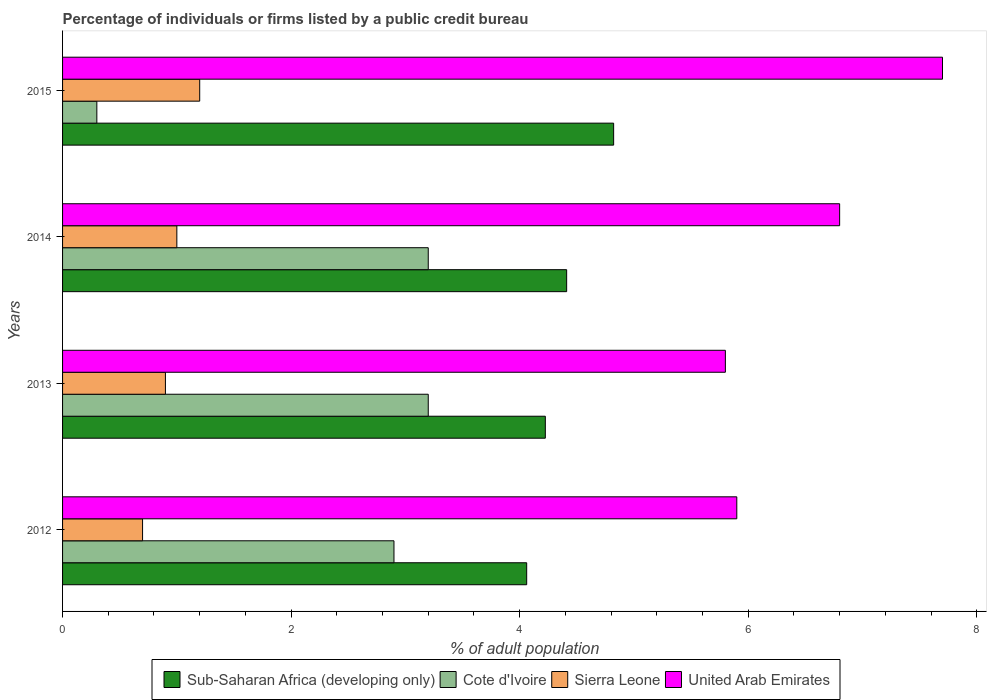How many different coloured bars are there?
Your answer should be compact. 4. How many bars are there on the 3rd tick from the bottom?
Your answer should be compact. 4. What is the label of the 1st group of bars from the top?
Provide a short and direct response. 2015. What is the percentage of population listed by a public credit bureau in Sub-Saharan Africa (developing only) in 2012?
Your answer should be very brief. 4.06. Across all years, what is the maximum percentage of population listed by a public credit bureau in Sierra Leone?
Ensure brevity in your answer.  1.2. Across all years, what is the minimum percentage of population listed by a public credit bureau in United Arab Emirates?
Offer a very short reply. 5.8. In which year was the percentage of population listed by a public credit bureau in United Arab Emirates maximum?
Provide a short and direct response. 2015. In which year was the percentage of population listed by a public credit bureau in Cote d'Ivoire minimum?
Provide a succinct answer. 2015. What is the total percentage of population listed by a public credit bureau in Sub-Saharan Africa (developing only) in the graph?
Your response must be concise. 17.52. What is the difference between the percentage of population listed by a public credit bureau in United Arab Emirates in 2013 and that in 2014?
Give a very brief answer. -1. What is the difference between the percentage of population listed by a public credit bureau in United Arab Emirates in 2013 and the percentage of population listed by a public credit bureau in Cote d'Ivoire in 2015?
Provide a succinct answer. 5.5. What is the average percentage of population listed by a public credit bureau in Sub-Saharan Africa (developing only) per year?
Offer a very short reply. 4.38. In the year 2015, what is the difference between the percentage of population listed by a public credit bureau in Sierra Leone and percentage of population listed by a public credit bureau in Cote d'Ivoire?
Your response must be concise. 0.9. In how many years, is the percentage of population listed by a public credit bureau in Cote d'Ivoire greater than 4.4 %?
Give a very brief answer. 0. What is the ratio of the percentage of population listed by a public credit bureau in Sub-Saharan Africa (developing only) in 2013 to that in 2015?
Offer a very short reply. 0.88. Is the percentage of population listed by a public credit bureau in Sub-Saharan Africa (developing only) in 2012 less than that in 2013?
Offer a very short reply. Yes. Is the difference between the percentage of population listed by a public credit bureau in Sierra Leone in 2013 and 2015 greater than the difference between the percentage of population listed by a public credit bureau in Cote d'Ivoire in 2013 and 2015?
Offer a terse response. No. What is the difference between the highest and the second highest percentage of population listed by a public credit bureau in Cote d'Ivoire?
Provide a succinct answer. 0. In how many years, is the percentage of population listed by a public credit bureau in Sierra Leone greater than the average percentage of population listed by a public credit bureau in Sierra Leone taken over all years?
Keep it short and to the point. 2. What does the 3rd bar from the top in 2014 represents?
Your response must be concise. Cote d'Ivoire. What does the 3rd bar from the bottom in 2012 represents?
Your answer should be very brief. Sierra Leone. How many bars are there?
Ensure brevity in your answer.  16. Are all the bars in the graph horizontal?
Provide a succinct answer. Yes. What is the difference between two consecutive major ticks on the X-axis?
Your answer should be compact. 2. Does the graph contain any zero values?
Offer a very short reply. No. Where does the legend appear in the graph?
Make the answer very short. Bottom center. How many legend labels are there?
Your response must be concise. 4. What is the title of the graph?
Your answer should be compact. Percentage of individuals or firms listed by a public credit bureau. Does "Pakistan" appear as one of the legend labels in the graph?
Provide a succinct answer. No. What is the label or title of the X-axis?
Ensure brevity in your answer.  % of adult population. What is the % of adult population of Sub-Saharan Africa (developing only) in 2012?
Provide a succinct answer. 4.06. What is the % of adult population of Cote d'Ivoire in 2012?
Ensure brevity in your answer.  2.9. What is the % of adult population of Sierra Leone in 2012?
Provide a succinct answer. 0.7. What is the % of adult population in Sub-Saharan Africa (developing only) in 2013?
Your answer should be very brief. 4.22. What is the % of adult population in Cote d'Ivoire in 2013?
Provide a short and direct response. 3.2. What is the % of adult population of Sierra Leone in 2013?
Make the answer very short. 0.9. What is the % of adult population of Sub-Saharan Africa (developing only) in 2014?
Your answer should be compact. 4.41. What is the % of adult population in United Arab Emirates in 2014?
Make the answer very short. 6.8. What is the % of adult population in Sub-Saharan Africa (developing only) in 2015?
Provide a short and direct response. 4.82. What is the % of adult population in Sierra Leone in 2015?
Give a very brief answer. 1.2. What is the % of adult population of United Arab Emirates in 2015?
Provide a short and direct response. 7.7. Across all years, what is the maximum % of adult population of Sub-Saharan Africa (developing only)?
Offer a terse response. 4.82. Across all years, what is the maximum % of adult population in Cote d'Ivoire?
Your answer should be compact. 3.2. Across all years, what is the maximum % of adult population of Sierra Leone?
Your answer should be compact. 1.2. Across all years, what is the minimum % of adult population of Sub-Saharan Africa (developing only)?
Keep it short and to the point. 4.06. Across all years, what is the minimum % of adult population of Cote d'Ivoire?
Make the answer very short. 0.3. Across all years, what is the minimum % of adult population of Sierra Leone?
Give a very brief answer. 0.7. Across all years, what is the minimum % of adult population of United Arab Emirates?
Your response must be concise. 5.8. What is the total % of adult population of Sub-Saharan Africa (developing only) in the graph?
Give a very brief answer. 17.52. What is the total % of adult population in Sierra Leone in the graph?
Offer a terse response. 3.8. What is the total % of adult population of United Arab Emirates in the graph?
Your answer should be very brief. 26.2. What is the difference between the % of adult population of Sub-Saharan Africa (developing only) in 2012 and that in 2013?
Make the answer very short. -0.16. What is the difference between the % of adult population of Sierra Leone in 2012 and that in 2013?
Provide a short and direct response. -0.2. What is the difference between the % of adult population of Sub-Saharan Africa (developing only) in 2012 and that in 2014?
Provide a short and direct response. -0.35. What is the difference between the % of adult population of Sierra Leone in 2012 and that in 2014?
Provide a succinct answer. -0.3. What is the difference between the % of adult population of United Arab Emirates in 2012 and that in 2014?
Your response must be concise. -0.9. What is the difference between the % of adult population in Sub-Saharan Africa (developing only) in 2012 and that in 2015?
Provide a succinct answer. -0.76. What is the difference between the % of adult population of Cote d'Ivoire in 2012 and that in 2015?
Your answer should be compact. 2.6. What is the difference between the % of adult population in Sierra Leone in 2012 and that in 2015?
Your answer should be very brief. -0.5. What is the difference between the % of adult population of United Arab Emirates in 2012 and that in 2015?
Make the answer very short. -1.8. What is the difference between the % of adult population in Sub-Saharan Africa (developing only) in 2013 and that in 2014?
Make the answer very short. -0.19. What is the difference between the % of adult population of Sierra Leone in 2013 and that in 2014?
Make the answer very short. -0.1. What is the difference between the % of adult population of Sub-Saharan Africa (developing only) in 2013 and that in 2015?
Give a very brief answer. -0.6. What is the difference between the % of adult population in Cote d'Ivoire in 2013 and that in 2015?
Offer a terse response. 2.9. What is the difference between the % of adult population in United Arab Emirates in 2013 and that in 2015?
Make the answer very short. -1.9. What is the difference between the % of adult population of Sub-Saharan Africa (developing only) in 2014 and that in 2015?
Ensure brevity in your answer.  -0.41. What is the difference between the % of adult population in Cote d'Ivoire in 2014 and that in 2015?
Keep it short and to the point. 2.9. What is the difference between the % of adult population in United Arab Emirates in 2014 and that in 2015?
Make the answer very short. -0.9. What is the difference between the % of adult population of Sub-Saharan Africa (developing only) in 2012 and the % of adult population of Cote d'Ivoire in 2013?
Your answer should be compact. 0.86. What is the difference between the % of adult population in Sub-Saharan Africa (developing only) in 2012 and the % of adult population in Sierra Leone in 2013?
Keep it short and to the point. 3.16. What is the difference between the % of adult population of Sub-Saharan Africa (developing only) in 2012 and the % of adult population of United Arab Emirates in 2013?
Your response must be concise. -1.74. What is the difference between the % of adult population of Cote d'Ivoire in 2012 and the % of adult population of Sierra Leone in 2013?
Your response must be concise. 2. What is the difference between the % of adult population in Cote d'Ivoire in 2012 and the % of adult population in United Arab Emirates in 2013?
Make the answer very short. -2.9. What is the difference between the % of adult population in Sierra Leone in 2012 and the % of adult population in United Arab Emirates in 2013?
Make the answer very short. -5.1. What is the difference between the % of adult population of Sub-Saharan Africa (developing only) in 2012 and the % of adult population of Cote d'Ivoire in 2014?
Provide a short and direct response. 0.86. What is the difference between the % of adult population in Sub-Saharan Africa (developing only) in 2012 and the % of adult population in Sierra Leone in 2014?
Ensure brevity in your answer.  3.06. What is the difference between the % of adult population in Sub-Saharan Africa (developing only) in 2012 and the % of adult population in United Arab Emirates in 2014?
Give a very brief answer. -2.74. What is the difference between the % of adult population of Cote d'Ivoire in 2012 and the % of adult population of United Arab Emirates in 2014?
Provide a short and direct response. -3.9. What is the difference between the % of adult population of Sub-Saharan Africa (developing only) in 2012 and the % of adult population of Cote d'Ivoire in 2015?
Make the answer very short. 3.76. What is the difference between the % of adult population of Sub-Saharan Africa (developing only) in 2012 and the % of adult population of Sierra Leone in 2015?
Your answer should be very brief. 2.86. What is the difference between the % of adult population of Sub-Saharan Africa (developing only) in 2012 and the % of adult population of United Arab Emirates in 2015?
Offer a terse response. -3.64. What is the difference between the % of adult population in Cote d'Ivoire in 2012 and the % of adult population in United Arab Emirates in 2015?
Give a very brief answer. -4.8. What is the difference between the % of adult population in Sierra Leone in 2012 and the % of adult population in United Arab Emirates in 2015?
Keep it short and to the point. -7. What is the difference between the % of adult population in Sub-Saharan Africa (developing only) in 2013 and the % of adult population in Cote d'Ivoire in 2014?
Offer a terse response. 1.02. What is the difference between the % of adult population of Sub-Saharan Africa (developing only) in 2013 and the % of adult population of Sierra Leone in 2014?
Provide a short and direct response. 3.22. What is the difference between the % of adult population in Sub-Saharan Africa (developing only) in 2013 and the % of adult population in United Arab Emirates in 2014?
Keep it short and to the point. -2.58. What is the difference between the % of adult population of Cote d'Ivoire in 2013 and the % of adult population of Sierra Leone in 2014?
Your answer should be very brief. 2.2. What is the difference between the % of adult population of Sub-Saharan Africa (developing only) in 2013 and the % of adult population of Cote d'Ivoire in 2015?
Keep it short and to the point. 3.92. What is the difference between the % of adult population in Sub-Saharan Africa (developing only) in 2013 and the % of adult population in Sierra Leone in 2015?
Make the answer very short. 3.02. What is the difference between the % of adult population in Sub-Saharan Africa (developing only) in 2013 and the % of adult population in United Arab Emirates in 2015?
Your answer should be very brief. -3.48. What is the difference between the % of adult population in Sub-Saharan Africa (developing only) in 2014 and the % of adult population in Cote d'Ivoire in 2015?
Offer a terse response. 4.11. What is the difference between the % of adult population in Sub-Saharan Africa (developing only) in 2014 and the % of adult population in Sierra Leone in 2015?
Offer a terse response. 3.21. What is the difference between the % of adult population in Sub-Saharan Africa (developing only) in 2014 and the % of adult population in United Arab Emirates in 2015?
Offer a terse response. -3.29. What is the difference between the % of adult population of Cote d'Ivoire in 2014 and the % of adult population of United Arab Emirates in 2015?
Your answer should be compact. -4.5. What is the difference between the % of adult population in Sierra Leone in 2014 and the % of adult population in United Arab Emirates in 2015?
Ensure brevity in your answer.  -6.7. What is the average % of adult population in Sub-Saharan Africa (developing only) per year?
Provide a succinct answer. 4.38. What is the average % of adult population in Cote d'Ivoire per year?
Your answer should be compact. 2.4. What is the average % of adult population of Sierra Leone per year?
Make the answer very short. 0.95. What is the average % of adult population of United Arab Emirates per year?
Keep it short and to the point. 6.55. In the year 2012, what is the difference between the % of adult population of Sub-Saharan Africa (developing only) and % of adult population of Cote d'Ivoire?
Your response must be concise. 1.16. In the year 2012, what is the difference between the % of adult population in Sub-Saharan Africa (developing only) and % of adult population in Sierra Leone?
Provide a short and direct response. 3.36. In the year 2012, what is the difference between the % of adult population of Sub-Saharan Africa (developing only) and % of adult population of United Arab Emirates?
Provide a short and direct response. -1.84. In the year 2013, what is the difference between the % of adult population of Sub-Saharan Africa (developing only) and % of adult population of Cote d'Ivoire?
Provide a succinct answer. 1.02. In the year 2013, what is the difference between the % of adult population in Sub-Saharan Africa (developing only) and % of adult population in Sierra Leone?
Keep it short and to the point. 3.32. In the year 2013, what is the difference between the % of adult population in Sub-Saharan Africa (developing only) and % of adult population in United Arab Emirates?
Provide a succinct answer. -1.58. In the year 2013, what is the difference between the % of adult population in Cote d'Ivoire and % of adult population in Sierra Leone?
Your answer should be compact. 2.3. In the year 2013, what is the difference between the % of adult population of Cote d'Ivoire and % of adult population of United Arab Emirates?
Make the answer very short. -2.6. In the year 2014, what is the difference between the % of adult population in Sub-Saharan Africa (developing only) and % of adult population in Cote d'Ivoire?
Offer a very short reply. 1.21. In the year 2014, what is the difference between the % of adult population in Sub-Saharan Africa (developing only) and % of adult population in Sierra Leone?
Provide a succinct answer. 3.41. In the year 2014, what is the difference between the % of adult population in Sub-Saharan Africa (developing only) and % of adult population in United Arab Emirates?
Offer a terse response. -2.39. In the year 2014, what is the difference between the % of adult population in Cote d'Ivoire and % of adult population in United Arab Emirates?
Give a very brief answer. -3.6. In the year 2015, what is the difference between the % of adult population of Sub-Saharan Africa (developing only) and % of adult population of Cote d'Ivoire?
Give a very brief answer. 4.52. In the year 2015, what is the difference between the % of adult population of Sub-Saharan Africa (developing only) and % of adult population of Sierra Leone?
Provide a succinct answer. 3.62. In the year 2015, what is the difference between the % of adult population of Sub-Saharan Africa (developing only) and % of adult population of United Arab Emirates?
Make the answer very short. -2.88. In the year 2015, what is the difference between the % of adult population in Cote d'Ivoire and % of adult population in Sierra Leone?
Ensure brevity in your answer.  -0.9. What is the ratio of the % of adult population of Sub-Saharan Africa (developing only) in 2012 to that in 2013?
Your answer should be very brief. 0.96. What is the ratio of the % of adult population of Cote d'Ivoire in 2012 to that in 2013?
Provide a short and direct response. 0.91. What is the ratio of the % of adult population in United Arab Emirates in 2012 to that in 2013?
Ensure brevity in your answer.  1.02. What is the ratio of the % of adult population in Sub-Saharan Africa (developing only) in 2012 to that in 2014?
Your response must be concise. 0.92. What is the ratio of the % of adult population of Cote d'Ivoire in 2012 to that in 2014?
Your response must be concise. 0.91. What is the ratio of the % of adult population in United Arab Emirates in 2012 to that in 2014?
Offer a terse response. 0.87. What is the ratio of the % of adult population in Sub-Saharan Africa (developing only) in 2012 to that in 2015?
Ensure brevity in your answer.  0.84. What is the ratio of the % of adult population of Cote d'Ivoire in 2012 to that in 2015?
Ensure brevity in your answer.  9.67. What is the ratio of the % of adult population in Sierra Leone in 2012 to that in 2015?
Offer a very short reply. 0.58. What is the ratio of the % of adult population in United Arab Emirates in 2012 to that in 2015?
Your answer should be very brief. 0.77. What is the ratio of the % of adult population in Sub-Saharan Africa (developing only) in 2013 to that in 2014?
Provide a short and direct response. 0.96. What is the ratio of the % of adult population in Sierra Leone in 2013 to that in 2014?
Offer a very short reply. 0.9. What is the ratio of the % of adult population of United Arab Emirates in 2013 to that in 2014?
Your answer should be very brief. 0.85. What is the ratio of the % of adult population in Sub-Saharan Africa (developing only) in 2013 to that in 2015?
Provide a short and direct response. 0.88. What is the ratio of the % of adult population in Cote d'Ivoire in 2013 to that in 2015?
Your answer should be compact. 10.67. What is the ratio of the % of adult population of United Arab Emirates in 2013 to that in 2015?
Provide a short and direct response. 0.75. What is the ratio of the % of adult population in Sub-Saharan Africa (developing only) in 2014 to that in 2015?
Your response must be concise. 0.91. What is the ratio of the % of adult population of Cote d'Ivoire in 2014 to that in 2015?
Offer a terse response. 10.67. What is the ratio of the % of adult population of United Arab Emirates in 2014 to that in 2015?
Give a very brief answer. 0.88. What is the difference between the highest and the second highest % of adult population in Sub-Saharan Africa (developing only)?
Give a very brief answer. 0.41. What is the difference between the highest and the second highest % of adult population of Cote d'Ivoire?
Provide a succinct answer. 0. What is the difference between the highest and the lowest % of adult population in Sub-Saharan Africa (developing only)?
Your response must be concise. 0.76. What is the difference between the highest and the lowest % of adult population in Sierra Leone?
Make the answer very short. 0.5. What is the difference between the highest and the lowest % of adult population of United Arab Emirates?
Provide a succinct answer. 1.9. 